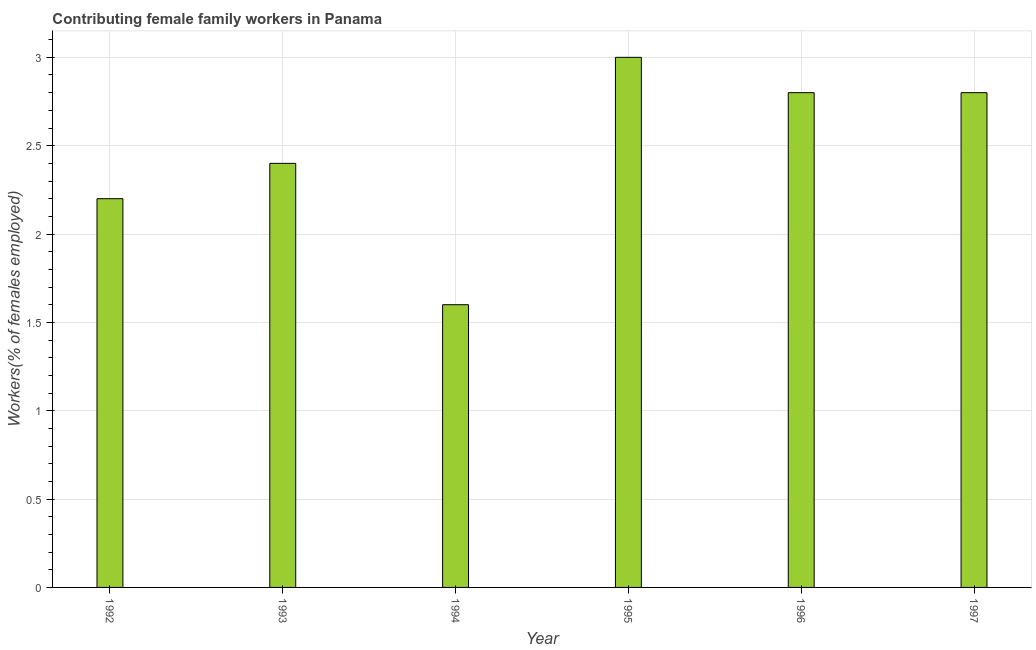Does the graph contain any zero values?
Provide a succinct answer. No. Does the graph contain grids?
Provide a short and direct response. Yes. What is the title of the graph?
Ensure brevity in your answer.  Contributing female family workers in Panama. What is the label or title of the X-axis?
Your answer should be compact. Year. What is the label or title of the Y-axis?
Your answer should be very brief. Workers(% of females employed). What is the contributing female family workers in 1996?
Offer a terse response. 2.8. Across all years, what is the maximum contributing female family workers?
Provide a short and direct response. 3. Across all years, what is the minimum contributing female family workers?
Your response must be concise. 1.6. In which year was the contributing female family workers minimum?
Offer a very short reply. 1994. What is the sum of the contributing female family workers?
Provide a succinct answer. 14.8. What is the average contributing female family workers per year?
Your answer should be very brief. 2.47. What is the median contributing female family workers?
Provide a succinct answer. 2.6. Do a majority of the years between 1995 and 1994 (inclusive) have contributing female family workers greater than 2.1 %?
Keep it short and to the point. No. What is the ratio of the contributing female family workers in 1996 to that in 1997?
Make the answer very short. 1. Is the contributing female family workers in 1992 less than that in 1993?
Ensure brevity in your answer.  Yes. Is the difference between the contributing female family workers in 1993 and 1995 greater than the difference between any two years?
Keep it short and to the point. No. Is the sum of the contributing female family workers in 1994 and 1997 greater than the maximum contributing female family workers across all years?
Provide a succinct answer. Yes. What is the difference between the highest and the lowest contributing female family workers?
Your answer should be compact. 1.4. In how many years, is the contributing female family workers greater than the average contributing female family workers taken over all years?
Offer a terse response. 3. How many bars are there?
Give a very brief answer. 6. What is the difference between two consecutive major ticks on the Y-axis?
Make the answer very short. 0.5. Are the values on the major ticks of Y-axis written in scientific E-notation?
Your answer should be very brief. No. What is the Workers(% of females employed) of 1992?
Your response must be concise. 2.2. What is the Workers(% of females employed) of 1993?
Keep it short and to the point. 2.4. What is the Workers(% of females employed) of 1994?
Offer a terse response. 1.6. What is the Workers(% of females employed) of 1996?
Ensure brevity in your answer.  2.8. What is the Workers(% of females employed) in 1997?
Keep it short and to the point. 2.8. What is the difference between the Workers(% of females employed) in 1992 and 1994?
Keep it short and to the point. 0.6. What is the difference between the Workers(% of females employed) in 1992 and 1995?
Make the answer very short. -0.8. What is the difference between the Workers(% of females employed) in 1995 and 1996?
Offer a terse response. 0.2. What is the difference between the Workers(% of females employed) in 1995 and 1997?
Your answer should be compact. 0.2. What is the difference between the Workers(% of females employed) in 1996 and 1997?
Provide a succinct answer. 0. What is the ratio of the Workers(% of females employed) in 1992 to that in 1993?
Provide a short and direct response. 0.92. What is the ratio of the Workers(% of females employed) in 1992 to that in 1994?
Make the answer very short. 1.38. What is the ratio of the Workers(% of females employed) in 1992 to that in 1995?
Provide a short and direct response. 0.73. What is the ratio of the Workers(% of females employed) in 1992 to that in 1996?
Your answer should be compact. 0.79. What is the ratio of the Workers(% of females employed) in 1992 to that in 1997?
Offer a very short reply. 0.79. What is the ratio of the Workers(% of females employed) in 1993 to that in 1995?
Your response must be concise. 0.8. What is the ratio of the Workers(% of females employed) in 1993 to that in 1996?
Keep it short and to the point. 0.86. What is the ratio of the Workers(% of females employed) in 1993 to that in 1997?
Offer a terse response. 0.86. What is the ratio of the Workers(% of females employed) in 1994 to that in 1995?
Keep it short and to the point. 0.53. What is the ratio of the Workers(% of females employed) in 1994 to that in 1996?
Ensure brevity in your answer.  0.57. What is the ratio of the Workers(% of females employed) in 1994 to that in 1997?
Your answer should be very brief. 0.57. What is the ratio of the Workers(% of females employed) in 1995 to that in 1996?
Offer a very short reply. 1.07. What is the ratio of the Workers(% of females employed) in 1995 to that in 1997?
Provide a succinct answer. 1.07. What is the ratio of the Workers(% of females employed) in 1996 to that in 1997?
Your answer should be compact. 1. 